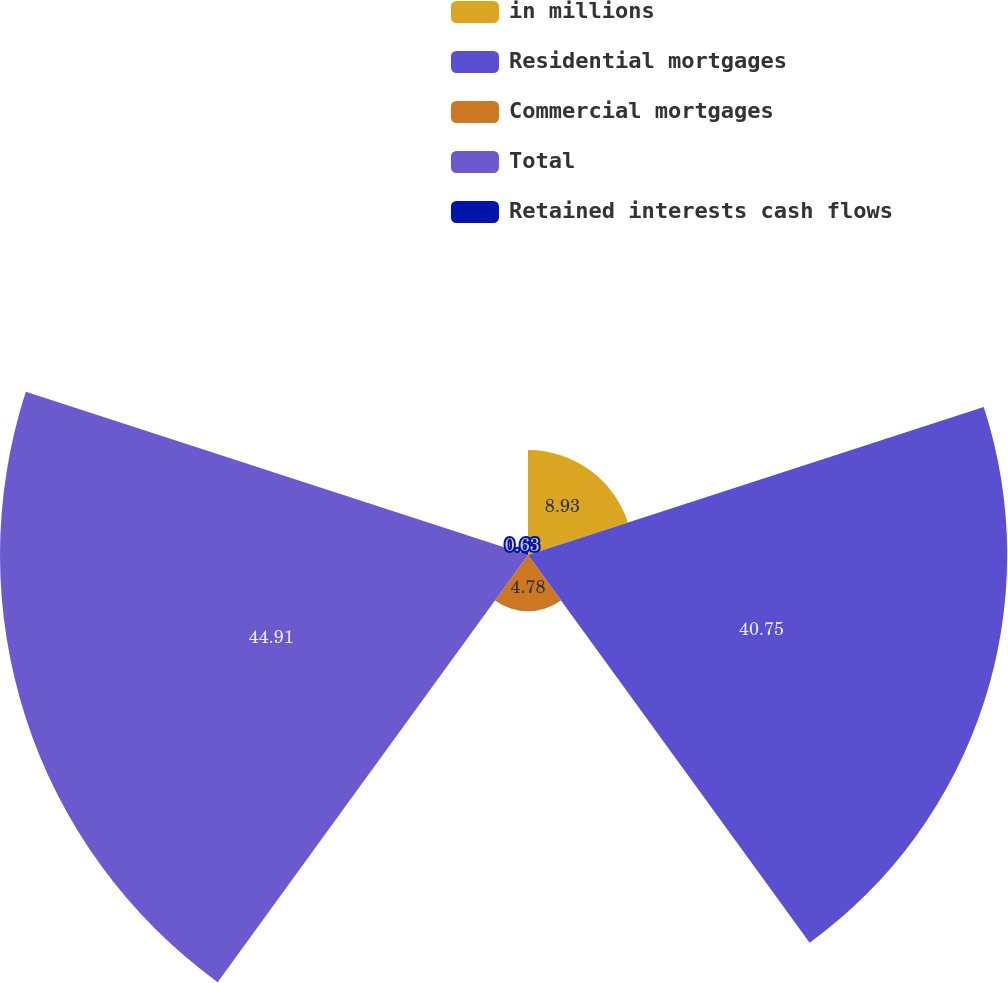<chart> <loc_0><loc_0><loc_500><loc_500><pie_chart><fcel>in millions<fcel>Residential mortgages<fcel>Commercial mortgages<fcel>Total<fcel>Retained interests cash flows<nl><fcel>8.93%<fcel>40.75%<fcel>4.78%<fcel>44.9%<fcel>0.63%<nl></chart> 